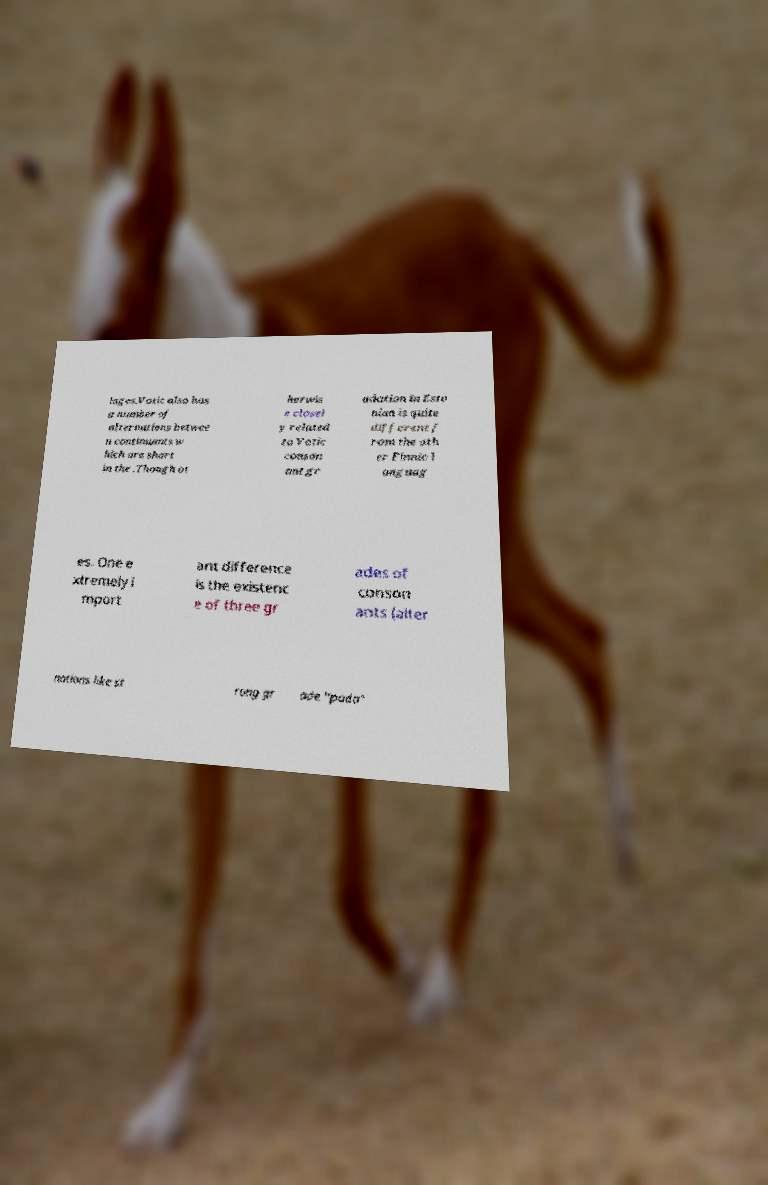Can you read and provide the text displayed in the image?This photo seems to have some interesting text. Can you extract and type it out for me? lages.Votic also has a number of alternations betwee n continuants w hich are short in the .Though ot herwis e closel y related to Votic conson ant gr adation in Esto nian is quite different f rom the oth er Finnic l anguag es. One e xtremely i mport ant difference is the existenc e of three gr ades of conson ants (alter nations like st rong gr ade "pada" 